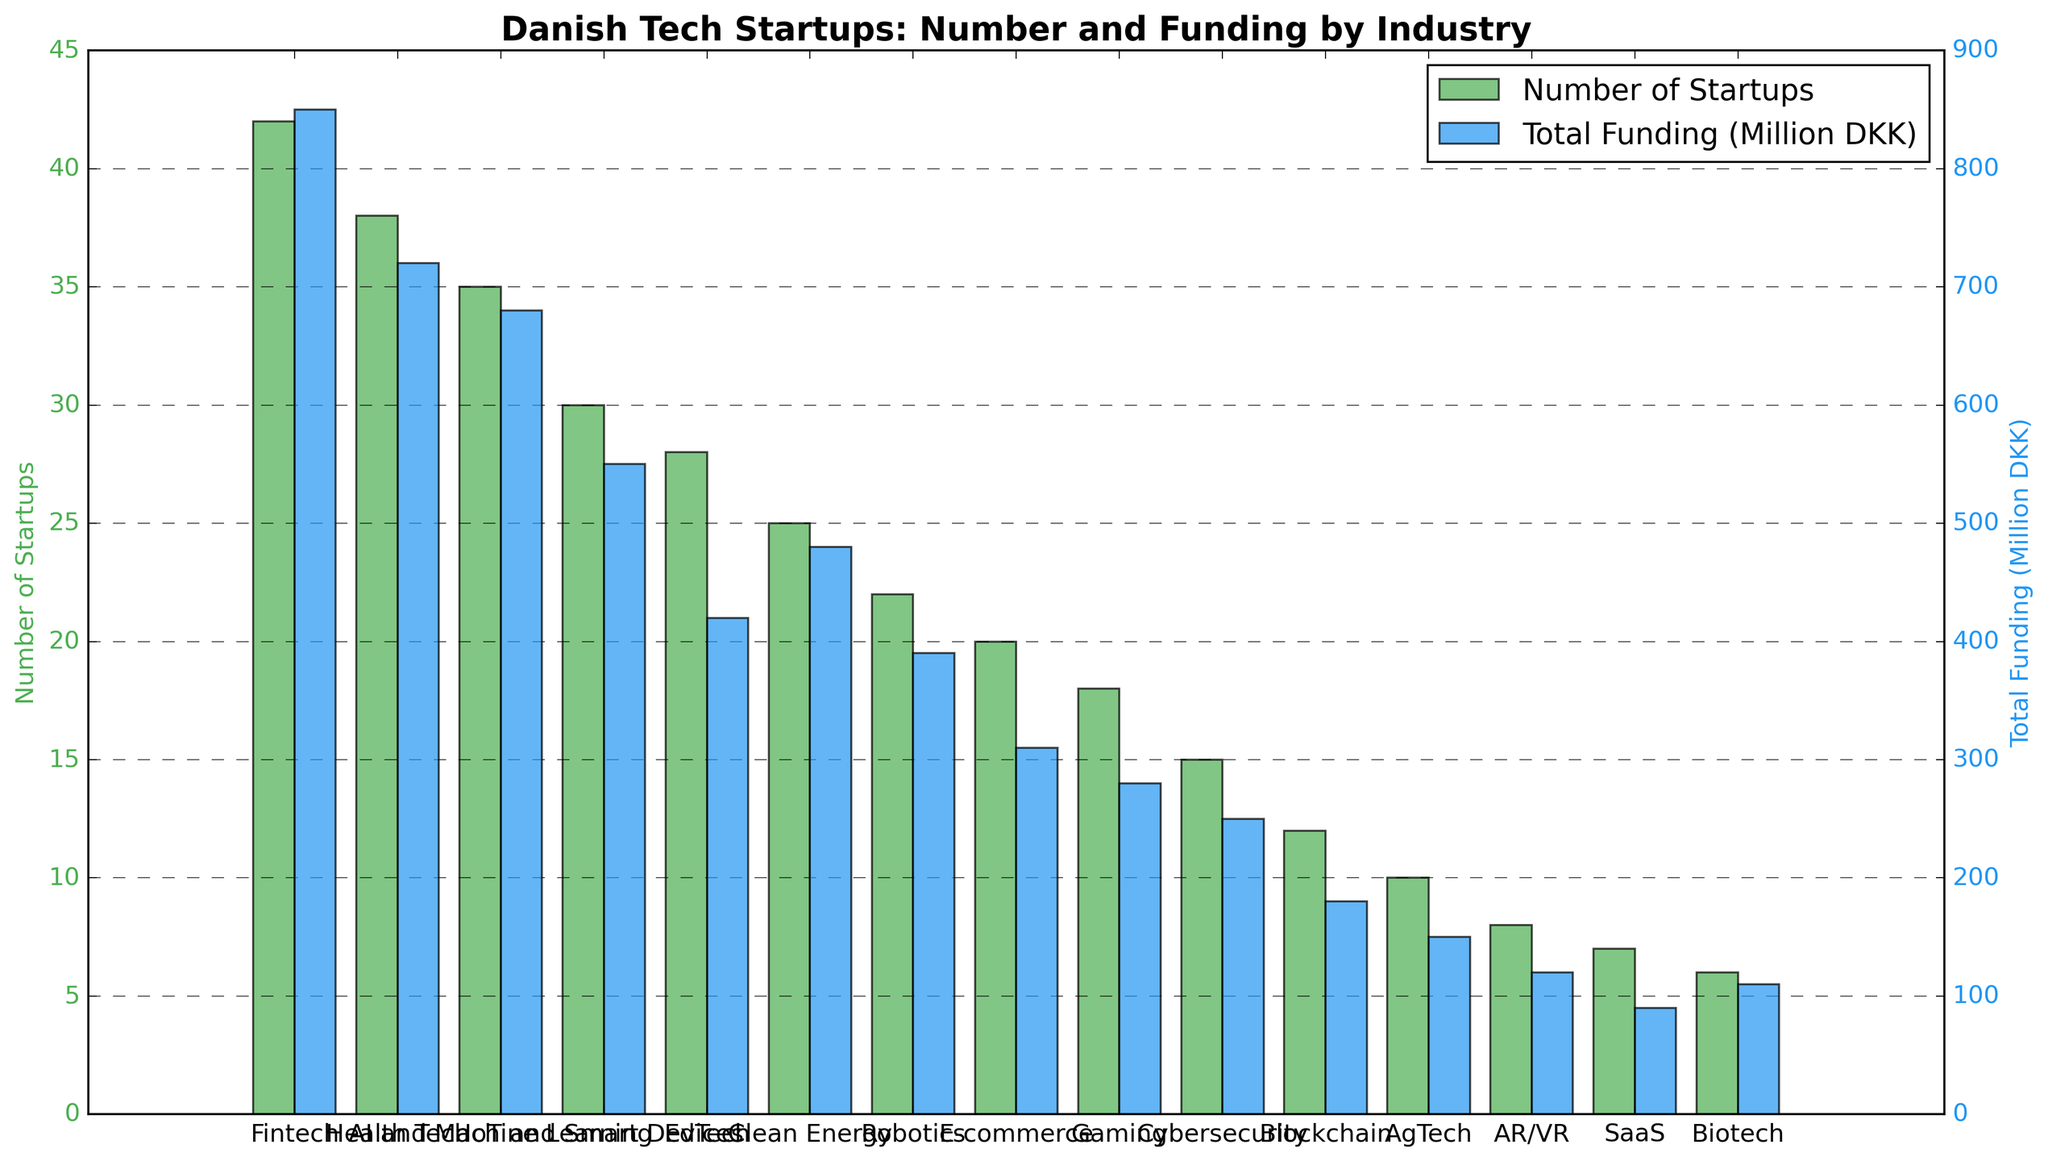what is the industry sector with the highest total funding? From the figure, identify the bar with the greatest height on the second y-axis that corresponds to total funding. The highest bar represents the Fintech industry sector.
Answer: Fintech which industry has the least number of startups? Look for the shortest bar on the first y-axis that represents the number of startups. This corresponds to the Biotech industry sector.
Answer: Biotech how does the total funding for Health Tech compare to that for IoT and Smart Devices? Identify the bars corresponding to Health Tech and IoT and Smart Devices on the second y-axis. Compare their heights to see if Health Tech's bar (720 million DKK) is higher than IoT and Smart Device's bar (550 million DKK).
Answer: Higher calculate the average total funding for Fintech, Health Tech, and AI and Machine Learning. Add the total funding amounts for Fintech (850), Health Tech (720), and AI and Machine Learning (680) and divide by the number of sectors (3). (850 + 720 + 680) / 3 = 750 million DKK
Answer: 750 million DKK what is the difference in the number of startups between EdTech and Clean Energy? Subtract the number of startups in Clean Energy (25) from the number of startups in EdTech (28). 28 - 25 = 3
Answer: 3 which sector has more startups, Gaming or Cybersecurity? Compare the heights of the bars representing the number of startups for Gaming (18) and Cybersecurity (15).
Answer: Gaming what is the average number of startups in the top 5 sectors by funding? Identify the top 5 sectors by funding: Fintech (42), Health Tech (38), AI and Machine Learning (35), IoT and Smart Devices (30), EdTech (28). Calculate the average: (42 + 38 + 35 + 30 + 28) / 5 = 34.6.
Answer: 34.6 which industry has the second highest total funding, and what is its value? Identify the bar with the second greatest height on the second y-axis corresponding to Health Tech with a value of 720 million DKK.
Answer: Health Tech, 720 million DKK are there more Clean Energy startups than Robotics startups? Compare the bar heights on the first y-axis for Clean Energy (25) and Robotics (22) to determine if Clean Energy has more startups.
Answer: Yes 